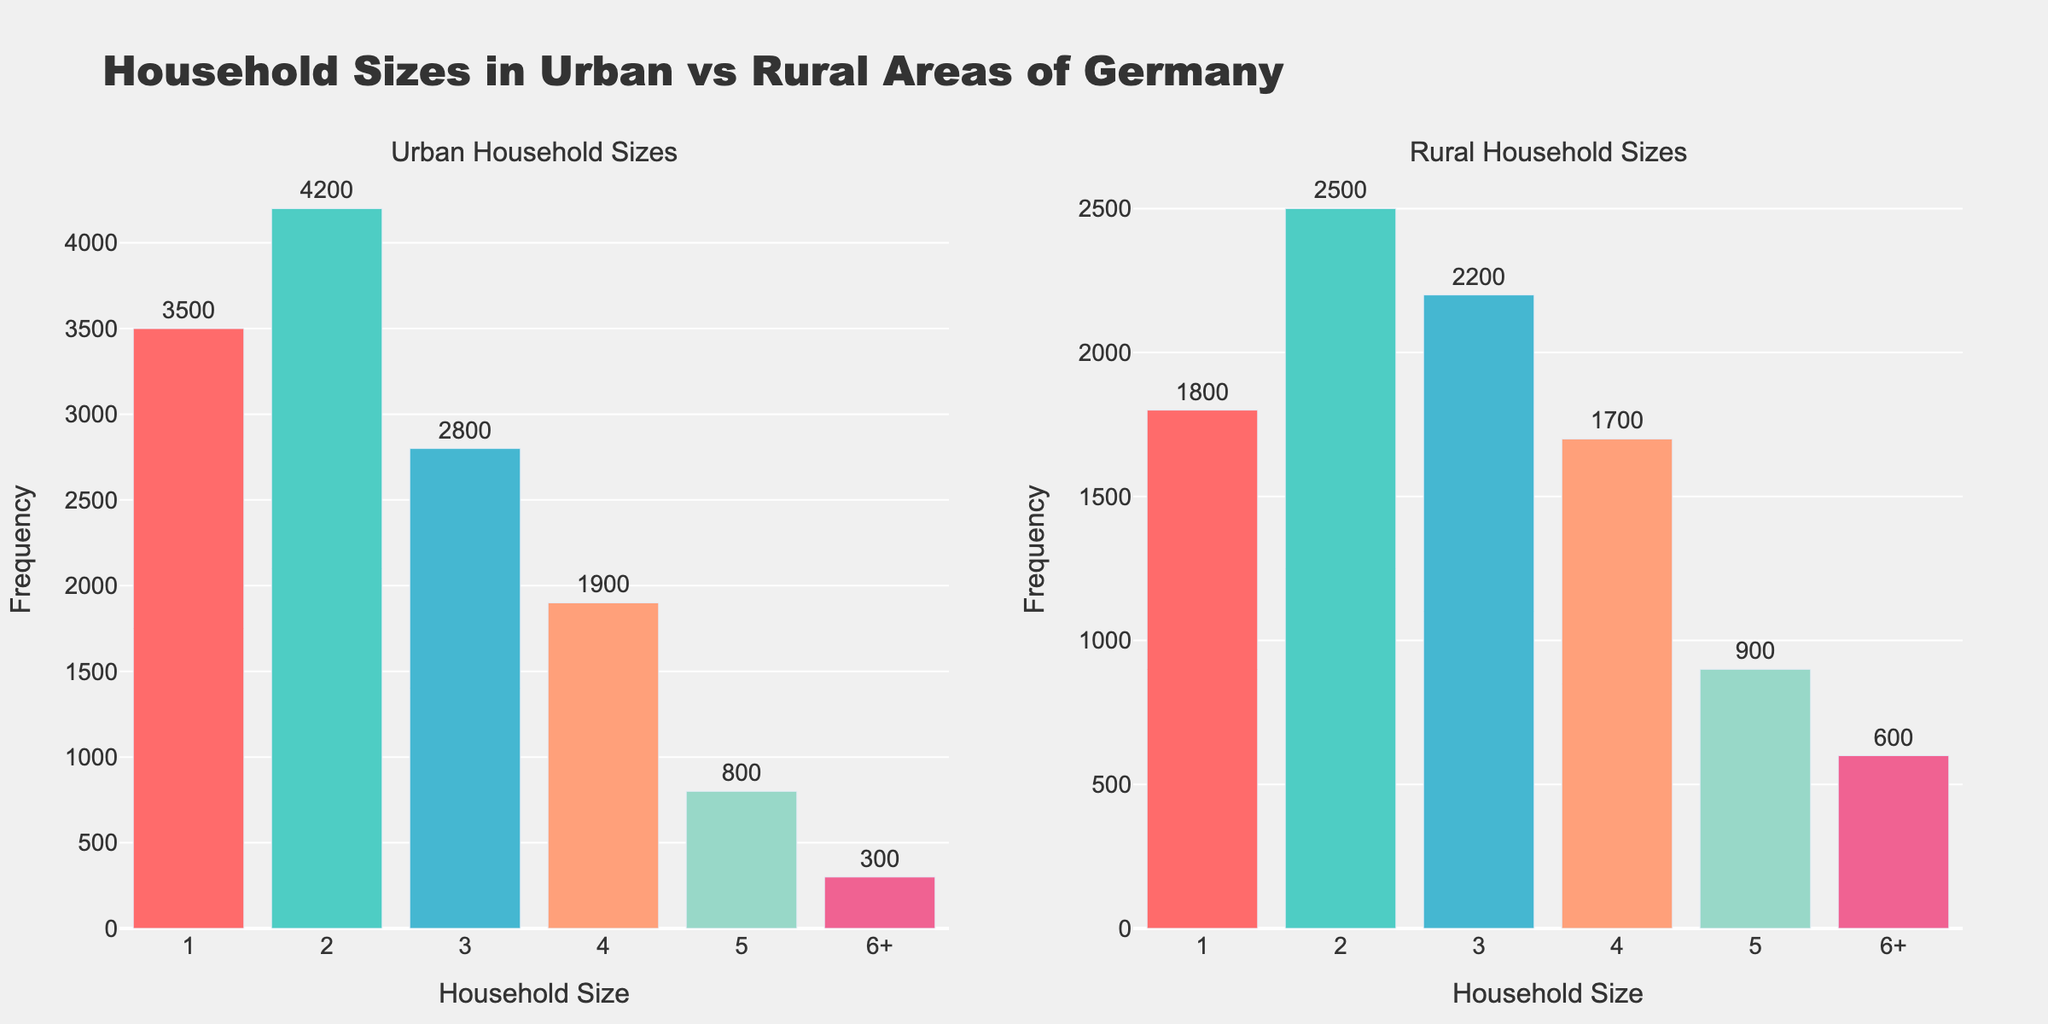How many household sizes are represented in the urban plot? The urban plot shows household sizes as individual categories on the x-axis ranging from 1 to 6+, making it a total of 6 categories represented.
Answer: 6 Which subplot has a higher frequency for 1-person households? By comparing the bar heights and the text values in the plots, the urban subplot shows a frequency of 3500, whereas the rural subplot shows a frequency of 1800 for 1-person households.
Answer: Urban What is the total number of households in the rural areas? By summing up the frequencies in the rural plot: 1800 (1) + 2500 (2) + 2200 (3) + 1700 (4) + 900 (5) + 600 (6+) = 9700.
Answer: 9700 How many more 2-person households are there in urban areas compared to rural areas? According to the plots, the frequency for 2-person households is 4200 in urban areas and 2500 in rural areas. The difference is 4200 - 2500 = 1700.
Answer: 1700 What's the most common household size in urban areas? The tallest bar in the urban subplot indicates the highest frequency. The 2-person household size has the highest frequency of 4200 in urban areas.
Answer: 2 Which area has a larger number of households with size 4? Comparing the text values above the bars for 4-person households, the urban subplot shows 1900, whereas the rural subplot shows 1700.
Answer: Urban Calculate the average household size for rural areas given the frequency distribution. The average household size is calculated by = (1*1800 + 2*2500 + 3*2200 + 4*1700 + 5*900 + 6.5*600) / 9700 = 3.11.
Answer: 3.11 In both subplots, which household size has the lowest frequency? By reviewing the bar heights and text values, the 6+ household size has the lowest frequency of 300 in urban areas and 600 in rural areas.
Answer: 6+ What's the total number of households in the urban areas? Summing the frequencies in the urban plot: 3500 (1) + 4200 (2) + 2800 (3) + 1900 (4) + 800 (5) + 300 (6+) = 13500.
Answer: 13500 Is there a household size that has a higher frequency in rural areas compared to urban areas? Comparing the frequencies for each household size in both subplots, the household size of 6+ has a frequency of 600 in rural areas compared to 300 in urban areas.
Answer: Yes 